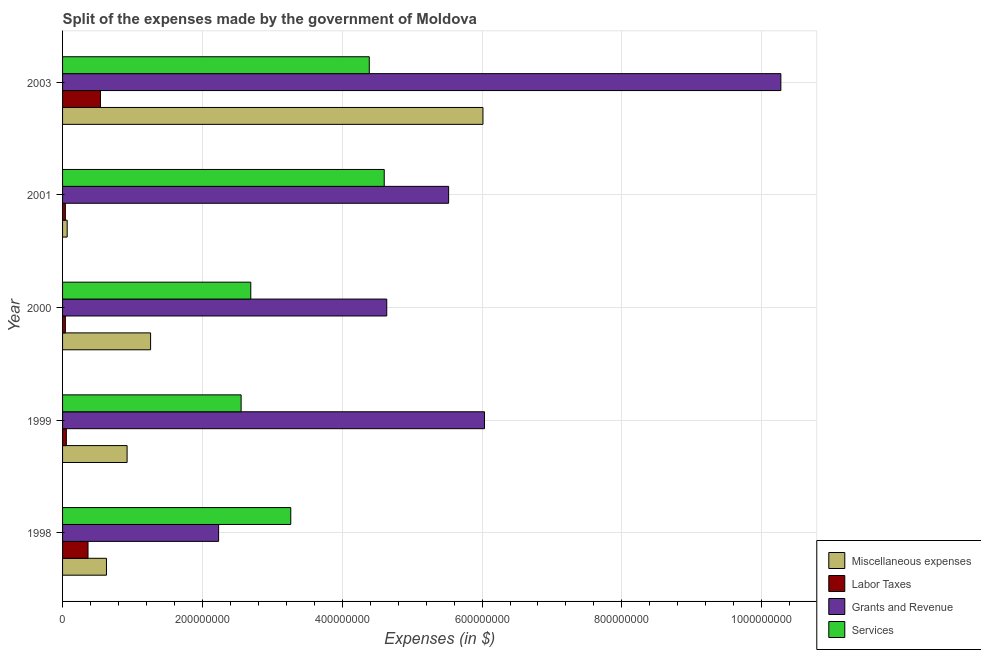How many different coloured bars are there?
Your answer should be compact. 4. What is the label of the 3rd group of bars from the top?
Provide a succinct answer. 2000. What is the amount spent on services in 2001?
Give a very brief answer. 4.60e+08. Across all years, what is the maximum amount spent on labor taxes?
Give a very brief answer. 5.42e+07. Across all years, what is the minimum amount spent on miscellaneous expenses?
Your answer should be compact. 6.60e+06. In which year was the amount spent on miscellaneous expenses maximum?
Provide a succinct answer. 2003. In which year was the amount spent on labor taxes minimum?
Provide a succinct answer. 2000. What is the total amount spent on grants and revenue in the graph?
Your response must be concise. 2.87e+09. What is the difference between the amount spent on miscellaneous expenses in 1998 and that in 1999?
Make the answer very short. -2.95e+07. What is the difference between the amount spent on grants and revenue in 2000 and the amount spent on miscellaneous expenses in 1998?
Keep it short and to the point. 4.01e+08. What is the average amount spent on grants and revenue per year?
Ensure brevity in your answer.  5.74e+08. In the year 1998, what is the difference between the amount spent on labor taxes and amount spent on miscellaneous expenses?
Your response must be concise. -2.64e+07. What is the ratio of the amount spent on grants and revenue in 2001 to that in 2003?
Your response must be concise. 0.54. Is the amount spent on labor taxes in 1998 less than that in 2001?
Offer a terse response. No. Is the difference between the amount spent on grants and revenue in 1999 and 2001 greater than the difference between the amount spent on services in 1999 and 2001?
Offer a terse response. Yes. What is the difference between the highest and the second highest amount spent on labor taxes?
Offer a terse response. 1.78e+07. What is the difference between the highest and the lowest amount spent on labor taxes?
Offer a terse response. 5.02e+07. In how many years, is the amount spent on miscellaneous expenses greater than the average amount spent on miscellaneous expenses taken over all years?
Offer a terse response. 1. What does the 4th bar from the top in 1998 represents?
Offer a terse response. Miscellaneous expenses. What does the 2nd bar from the bottom in 1998 represents?
Ensure brevity in your answer.  Labor Taxes. How many years are there in the graph?
Your response must be concise. 5. What is the difference between two consecutive major ticks on the X-axis?
Offer a very short reply. 2.00e+08. Are the values on the major ticks of X-axis written in scientific E-notation?
Your response must be concise. No. Does the graph contain any zero values?
Offer a very short reply. No. Does the graph contain grids?
Offer a terse response. Yes. Where does the legend appear in the graph?
Offer a terse response. Bottom right. How are the legend labels stacked?
Provide a succinct answer. Vertical. What is the title of the graph?
Keep it short and to the point. Split of the expenses made by the government of Moldova. Does "Bird species" appear as one of the legend labels in the graph?
Make the answer very short. No. What is the label or title of the X-axis?
Offer a very short reply. Expenses (in $). What is the Expenses (in $) in Miscellaneous expenses in 1998?
Offer a very short reply. 6.28e+07. What is the Expenses (in $) of Labor Taxes in 1998?
Make the answer very short. 3.64e+07. What is the Expenses (in $) of Grants and Revenue in 1998?
Provide a short and direct response. 2.23e+08. What is the Expenses (in $) of Services in 1998?
Ensure brevity in your answer.  3.26e+08. What is the Expenses (in $) in Miscellaneous expenses in 1999?
Give a very brief answer. 9.23e+07. What is the Expenses (in $) of Labor Taxes in 1999?
Ensure brevity in your answer.  5.40e+06. What is the Expenses (in $) in Grants and Revenue in 1999?
Offer a terse response. 6.04e+08. What is the Expenses (in $) of Services in 1999?
Your answer should be very brief. 2.55e+08. What is the Expenses (in $) in Miscellaneous expenses in 2000?
Your answer should be compact. 1.26e+08. What is the Expenses (in $) of Labor Taxes in 2000?
Your response must be concise. 4.00e+06. What is the Expenses (in $) in Grants and Revenue in 2000?
Give a very brief answer. 4.64e+08. What is the Expenses (in $) of Services in 2000?
Offer a very short reply. 2.69e+08. What is the Expenses (in $) of Miscellaneous expenses in 2001?
Offer a very short reply. 6.60e+06. What is the Expenses (in $) in Grants and Revenue in 2001?
Make the answer very short. 5.52e+08. What is the Expenses (in $) of Services in 2001?
Ensure brevity in your answer.  4.60e+08. What is the Expenses (in $) of Miscellaneous expenses in 2003?
Ensure brevity in your answer.  6.01e+08. What is the Expenses (in $) in Labor Taxes in 2003?
Provide a short and direct response. 5.42e+07. What is the Expenses (in $) of Grants and Revenue in 2003?
Offer a terse response. 1.03e+09. What is the Expenses (in $) of Services in 2003?
Offer a very short reply. 4.39e+08. Across all years, what is the maximum Expenses (in $) of Miscellaneous expenses?
Provide a succinct answer. 6.01e+08. Across all years, what is the maximum Expenses (in $) of Labor Taxes?
Offer a very short reply. 5.42e+07. Across all years, what is the maximum Expenses (in $) of Grants and Revenue?
Give a very brief answer. 1.03e+09. Across all years, what is the maximum Expenses (in $) in Services?
Offer a terse response. 4.60e+08. Across all years, what is the minimum Expenses (in $) of Miscellaneous expenses?
Provide a succinct answer. 6.60e+06. Across all years, what is the minimum Expenses (in $) of Labor Taxes?
Offer a very short reply. 4.00e+06. Across all years, what is the minimum Expenses (in $) of Grants and Revenue?
Give a very brief answer. 2.23e+08. Across all years, what is the minimum Expenses (in $) of Services?
Your answer should be very brief. 2.55e+08. What is the total Expenses (in $) in Miscellaneous expenses in the graph?
Give a very brief answer. 8.89e+08. What is the total Expenses (in $) in Labor Taxes in the graph?
Offer a terse response. 1.04e+08. What is the total Expenses (in $) of Grants and Revenue in the graph?
Your answer should be compact. 2.87e+09. What is the total Expenses (in $) in Services in the graph?
Your response must be concise. 1.75e+09. What is the difference between the Expenses (in $) of Miscellaneous expenses in 1998 and that in 1999?
Give a very brief answer. -2.95e+07. What is the difference between the Expenses (in $) of Labor Taxes in 1998 and that in 1999?
Give a very brief answer. 3.10e+07. What is the difference between the Expenses (in $) in Grants and Revenue in 1998 and that in 1999?
Your response must be concise. -3.80e+08. What is the difference between the Expenses (in $) in Services in 1998 and that in 1999?
Provide a succinct answer. 7.10e+07. What is the difference between the Expenses (in $) of Miscellaneous expenses in 1998 and that in 2000?
Give a very brief answer. -6.31e+07. What is the difference between the Expenses (in $) of Labor Taxes in 1998 and that in 2000?
Make the answer very short. 3.24e+07. What is the difference between the Expenses (in $) of Grants and Revenue in 1998 and that in 2000?
Your response must be concise. -2.40e+08. What is the difference between the Expenses (in $) in Services in 1998 and that in 2000?
Your answer should be very brief. 5.72e+07. What is the difference between the Expenses (in $) of Miscellaneous expenses in 1998 and that in 2001?
Keep it short and to the point. 5.62e+07. What is the difference between the Expenses (in $) of Labor Taxes in 1998 and that in 2001?
Your answer should be compact. 3.24e+07. What is the difference between the Expenses (in $) in Grants and Revenue in 1998 and that in 2001?
Ensure brevity in your answer.  -3.29e+08. What is the difference between the Expenses (in $) in Services in 1998 and that in 2001?
Provide a succinct answer. -1.34e+08. What is the difference between the Expenses (in $) of Miscellaneous expenses in 1998 and that in 2003?
Offer a very short reply. -5.38e+08. What is the difference between the Expenses (in $) of Labor Taxes in 1998 and that in 2003?
Your answer should be compact. -1.78e+07. What is the difference between the Expenses (in $) in Grants and Revenue in 1998 and that in 2003?
Your response must be concise. -8.04e+08. What is the difference between the Expenses (in $) of Services in 1998 and that in 2003?
Offer a very short reply. -1.12e+08. What is the difference between the Expenses (in $) of Miscellaneous expenses in 1999 and that in 2000?
Your answer should be very brief. -3.36e+07. What is the difference between the Expenses (in $) in Labor Taxes in 1999 and that in 2000?
Make the answer very short. 1.40e+06. What is the difference between the Expenses (in $) in Grants and Revenue in 1999 and that in 2000?
Your answer should be compact. 1.40e+08. What is the difference between the Expenses (in $) of Services in 1999 and that in 2000?
Make the answer very short. -1.38e+07. What is the difference between the Expenses (in $) of Miscellaneous expenses in 1999 and that in 2001?
Make the answer very short. 8.57e+07. What is the difference between the Expenses (in $) of Labor Taxes in 1999 and that in 2001?
Your answer should be very brief. 1.40e+06. What is the difference between the Expenses (in $) in Grants and Revenue in 1999 and that in 2001?
Keep it short and to the point. 5.13e+07. What is the difference between the Expenses (in $) of Services in 1999 and that in 2001?
Your answer should be very brief. -2.05e+08. What is the difference between the Expenses (in $) of Miscellaneous expenses in 1999 and that in 2003?
Provide a succinct answer. -5.09e+08. What is the difference between the Expenses (in $) in Labor Taxes in 1999 and that in 2003?
Provide a succinct answer. -4.88e+07. What is the difference between the Expenses (in $) in Grants and Revenue in 1999 and that in 2003?
Give a very brief answer. -4.24e+08. What is the difference between the Expenses (in $) in Services in 1999 and that in 2003?
Your response must be concise. -1.83e+08. What is the difference between the Expenses (in $) in Miscellaneous expenses in 2000 and that in 2001?
Your answer should be compact. 1.19e+08. What is the difference between the Expenses (in $) of Grants and Revenue in 2000 and that in 2001?
Make the answer very short. -8.85e+07. What is the difference between the Expenses (in $) in Services in 2000 and that in 2001?
Ensure brevity in your answer.  -1.91e+08. What is the difference between the Expenses (in $) in Miscellaneous expenses in 2000 and that in 2003?
Make the answer very short. -4.75e+08. What is the difference between the Expenses (in $) of Labor Taxes in 2000 and that in 2003?
Provide a short and direct response. -5.02e+07. What is the difference between the Expenses (in $) of Grants and Revenue in 2000 and that in 2003?
Ensure brevity in your answer.  -5.64e+08. What is the difference between the Expenses (in $) in Services in 2000 and that in 2003?
Make the answer very short. -1.70e+08. What is the difference between the Expenses (in $) of Miscellaneous expenses in 2001 and that in 2003?
Give a very brief answer. -5.95e+08. What is the difference between the Expenses (in $) in Labor Taxes in 2001 and that in 2003?
Offer a very short reply. -5.02e+07. What is the difference between the Expenses (in $) in Grants and Revenue in 2001 and that in 2003?
Give a very brief answer. -4.75e+08. What is the difference between the Expenses (in $) of Services in 2001 and that in 2003?
Your response must be concise. 2.14e+07. What is the difference between the Expenses (in $) of Miscellaneous expenses in 1998 and the Expenses (in $) of Labor Taxes in 1999?
Your response must be concise. 5.74e+07. What is the difference between the Expenses (in $) of Miscellaneous expenses in 1998 and the Expenses (in $) of Grants and Revenue in 1999?
Offer a terse response. -5.41e+08. What is the difference between the Expenses (in $) in Miscellaneous expenses in 1998 and the Expenses (in $) in Services in 1999?
Provide a succinct answer. -1.93e+08. What is the difference between the Expenses (in $) in Labor Taxes in 1998 and the Expenses (in $) in Grants and Revenue in 1999?
Offer a very short reply. -5.67e+08. What is the difference between the Expenses (in $) of Labor Taxes in 1998 and the Expenses (in $) of Services in 1999?
Provide a succinct answer. -2.19e+08. What is the difference between the Expenses (in $) of Grants and Revenue in 1998 and the Expenses (in $) of Services in 1999?
Your answer should be very brief. -3.22e+07. What is the difference between the Expenses (in $) in Miscellaneous expenses in 1998 and the Expenses (in $) in Labor Taxes in 2000?
Your answer should be very brief. 5.88e+07. What is the difference between the Expenses (in $) in Miscellaneous expenses in 1998 and the Expenses (in $) in Grants and Revenue in 2000?
Offer a terse response. -4.01e+08. What is the difference between the Expenses (in $) in Miscellaneous expenses in 1998 and the Expenses (in $) in Services in 2000?
Offer a very short reply. -2.06e+08. What is the difference between the Expenses (in $) in Labor Taxes in 1998 and the Expenses (in $) in Grants and Revenue in 2000?
Your answer should be compact. -4.27e+08. What is the difference between the Expenses (in $) of Labor Taxes in 1998 and the Expenses (in $) of Services in 2000?
Make the answer very short. -2.33e+08. What is the difference between the Expenses (in $) of Grants and Revenue in 1998 and the Expenses (in $) of Services in 2000?
Keep it short and to the point. -4.60e+07. What is the difference between the Expenses (in $) of Miscellaneous expenses in 1998 and the Expenses (in $) of Labor Taxes in 2001?
Give a very brief answer. 5.88e+07. What is the difference between the Expenses (in $) in Miscellaneous expenses in 1998 and the Expenses (in $) in Grants and Revenue in 2001?
Your answer should be very brief. -4.89e+08. What is the difference between the Expenses (in $) in Miscellaneous expenses in 1998 and the Expenses (in $) in Services in 2001?
Your answer should be compact. -3.97e+08. What is the difference between the Expenses (in $) of Labor Taxes in 1998 and the Expenses (in $) of Grants and Revenue in 2001?
Give a very brief answer. -5.16e+08. What is the difference between the Expenses (in $) in Labor Taxes in 1998 and the Expenses (in $) in Services in 2001?
Your answer should be compact. -4.24e+08. What is the difference between the Expenses (in $) in Grants and Revenue in 1998 and the Expenses (in $) in Services in 2001?
Your answer should be very brief. -2.37e+08. What is the difference between the Expenses (in $) in Miscellaneous expenses in 1998 and the Expenses (in $) in Labor Taxes in 2003?
Provide a short and direct response. 8.60e+06. What is the difference between the Expenses (in $) of Miscellaneous expenses in 1998 and the Expenses (in $) of Grants and Revenue in 2003?
Make the answer very short. -9.65e+08. What is the difference between the Expenses (in $) in Miscellaneous expenses in 1998 and the Expenses (in $) in Services in 2003?
Make the answer very short. -3.76e+08. What is the difference between the Expenses (in $) of Labor Taxes in 1998 and the Expenses (in $) of Grants and Revenue in 2003?
Your answer should be very brief. -9.91e+08. What is the difference between the Expenses (in $) of Labor Taxes in 1998 and the Expenses (in $) of Services in 2003?
Provide a succinct answer. -4.02e+08. What is the difference between the Expenses (in $) of Grants and Revenue in 1998 and the Expenses (in $) of Services in 2003?
Ensure brevity in your answer.  -2.16e+08. What is the difference between the Expenses (in $) in Miscellaneous expenses in 1999 and the Expenses (in $) in Labor Taxes in 2000?
Make the answer very short. 8.83e+07. What is the difference between the Expenses (in $) of Miscellaneous expenses in 1999 and the Expenses (in $) of Grants and Revenue in 2000?
Provide a short and direct response. -3.71e+08. What is the difference between the Expenses (in $) in Miscellaneous expenses in 1999 and the Expenses (in $) in Services in 2000?
Provide a succinct answer. -1.77e+08. What is the difference between the Expenses (in $) in Labor Taxes in 1999 and the Expenses (in $) in Grants and Revenue in 2000?
Give a very brief answer. -4.58e+08. What is the difference between the Expenses (in $) of Labor Taxes in 1999 and the Expenses (in $) of Services in 2000?
Give a very brief answer. -2.64e+08. What is the difference between the Expenses (in $) in Grants and Revenue in 1999 and the Expenses (in $) in Services in 2000?
Make the answer very short. 3.34e+08. What is the difference between the Expenses (in $) of Miscellaneous expenses in 1999 and the Expenses (in $) of Labor Taxes in 2001?
Your answer should be very brief. 8.83e+07. What is the difference between the Expenses (in $) of Miscellaneous expenses in 1999 and the Expenses (in $) of Grants and Revenue in 2001?
Your response must be concise. -4.60e+08. What is the difference between the Expenses (in $) of Miscellaneous expenses in 1999 and the Expenses (in $) of Services in 2001?
Offer a very short reply. -3.68e+08. What is the difference between the Expenses (in $) of Labor Taxes in 1999 and the Expenses (in $) of Grants and Revenue in 2001?
Make the answer very short. -5.47e+08. What is the difference between the Expenses (in $) in Labor Taxes in 1999 and the Expenses (in $) in Services in 2001?
Offer a terse response. -4.55e+08. What is the difference between the Expenses (in $) in Grants and Revenue in 1999 and the Expenses (in $) in Services in 2001?
Provide a short and direct response. 1.43e+08. What is the difference between the Expenses (in $) in Miscellaneous expenses in 1999 and the Expenses (in $) in Labor Taxes in 2003?
Your answer should be compact. 3.81e+07. What is the difference between the Expenses (in $) of Miscellaneous expenses in 1999 and the Expenses (in $) of Grants and Revenue in 2003?
Make the answer very short. -9.35e+08. What is the difference between the Expenses (in $) of Miscellaneous expenses in 1999 and the Expenses (in $) of Services in 2003?
Your response must be concise. -3.46e+08. What is the difference between the Expenses (in $) in Labor Taxes in 1999 and the Expenses (in $) in Grants and Revenue in 2003?
Ensure brevity in your answer.  -1.02e+09. What is the difference between the Expenses (in $) of Labor Taxes in 1999 and the Expenses (in $) of Services in 2003?
Provide a succinct answer. -4.33e+08. What is the difference between the Expenses (in $) in Grants and Revenue in 1999 and the Expenses (in $) in Services in 2003?
Make the answer very short. 1.65e+08. What is the difference between the Expenses (in $) of Miscellaneous expenses in 2000 and the Expenses (in $) of Labor Taxes in 2001?
Ensure brevity in your answer.  1.22e+08. What is the difference between the Expenses (in $) in Miscellaneous expenses in 2000 and the Expenses (in $) in Grants and Revenue in 2001?
Give a very brief answer. -4.26e+08. What is the difference between the Expenses (in $) of Miscellaneous expenses in 2000 and the Expenses (in $) of Services in 2001?
Your answer should be very brief. -3.34e+08. What is the difference between the Expenses (in $) of Labor Taxes in 2000 and the Expenses (in $) of Grants and Revenue in 2001?
Give a very brief answer. -5.48e+08. What is the difference between the Expenses (in $) of Labor Taxes in 2000 and the Expenses (in $) of Services in 2001?
Ensure brevity in your answer.  -4.56e+08. What is the difference between the Expenses (in $) in Grants and Revenue in 2000 and the Expenses (in $) in Services in 2001?
Provide a short and direct response. 3.60e+06. What is the difference between the Expenses (in $) of Miscellaneous expenses in 2000 and the Expenses (in $) of Labor Taxes in 2003?
Offer a terse response. 7.17e+07. What is the difference between the Expenses (in $) in Miscellaneous expenses in 2000 and the Expenses (in $) in Grants and Revenue in 2003?
Ensure brevity in your answer.  -9.02e+08. What is the difference between the Expenses (in $) of Miscellaneous expenses in 2000 and the Expenses (in $) of Services in 2003?
Offer a very short reply. -3.13e+08. What is the difference between the Expenses (in $) of Labor Taxes in 2000 and the Expenses (in $) of Grants and Revenue in 2003?
Give a very brief answer. -1.02e+09. What is the difference between the Expenses (in $) of Labor Taxes in 2000 and the Expenses (in $) of Services in 2003?
Give a very brief answer. -4.35e+08. What is the difference between the Expenses (in $) of Grants and Revenue in 2000 and the Expenses (in $) of Services in 2003?
Offer a very short reply. 2.50e+07. What is the difference between the Expenses (in $) of Miscellaneous expenses in 2001 and the Expenses (in $) of Labor Taxes in 2003?
Provide a succinct answer. -4.76e+07. What is the difference between the Expenses (in $) of Miscellaneous expenses in 2001 and the Expenses (in $) of Grants and Revenue in 2003?
Provide a succinct answer. -1.02e+09. What is the difference between the Expenses (in $) in Miscellaneous expenses in 2001 and the Expenses (in $) in Services in 2003?
Provide a succinct answer. -4.32e+08. What is the difference between the Expenses (in $) of Labor Taxes in 2001 and the Expenses (in $) of Grants and Revenue in 2003?
Your answer should be very brief. -1.02e+09. What is the difference between the Expenses (in $) of Labor Taxes in 2001 and the Expenses (in $) of Services in 2003?
Offer a very short reply. -4.35e+08. What is the difference between the Expenses (in $) of Grants and Revenue in 2001 and the Expenses (in $) of Services in 2003?
Make the answer very short. 1.14e+08. What is the average Expenses (in $) of Miscellaneous expenses per year?
Provide a short and direct response. 1.78e+08. What is the average Expenses (in $) of Labor Taxes per year?
Give a very brief answer. 2.08e+07. What is the average Expenses (in $) of Grants and Revenue per year?
Offer a very short reply. 5.74e+08. What is the average Expenses (in $) in Services per year?
Keep it short and to the point. 3.50e+08. In the year 1998, what is the difference between the Expenses (in $) of Miscellaneous expenses and Expenses (in $) of Labor Taxes?
Your answer should be very brief. 2.64e+07. In the year 1998, what is the difference between the Expenses (in $) of Miscellaneous expenses and Expenses (in $) of Grants and Revenue?
Your response must be concise. -1.60e+08. In the year 1998, what is the difference between the Expenses (in $) in Miscellaneous expenses and Expenses (in $) in Services?
Ensure brevity in your answer.  -2.64e+08. In the year 1998, what is the difference between the Expenses (in $) of Labor Taxes and Expenses (in $) of Grants and Revenue?
Your answer should be very brief. -1.87e+08. In the year 1998, what is the difference between the Expenses (in $) in Labor Taxes and Expenses (in $) in Services?
Keep it short and to the point. -2.90e+08. In the year 1998, what is the difference between the Expenses (in $) in Grants and Revenue and Expenses (in $) in Services?
Offer a very short reply. -1.03e+08. In the year 1999, what is the difference between the Expenses (in $) of Miscellaneous expenses and Expenses (in $) of Labor Taxes?
Provide a short and direct response. 8.69e+07. In the year 1999, what is the difference between the Expenses (in $) of Miscellaneous expenses and Expenses (in $) of Grants and Revenue?
Ensure brevity in your answer.  -5.11e+08. In the year 1999, what is the difference between the Expenses (in $) of Miscellaneous expenses and Expenses (in $) of Services?
Your answer should be very brief. -1.63e+08. In the year 1999, what is the difference between the Expenses (in $) of Labor Taxes and Expenses (in $) of Grants and Revenue?
Your answer should be very brief. -5.98e+08. In the year 1999, what is the difference between the Expenses (in $) of Labor Taxes and Expenses (in $) of Services?
Give a very brief answer. -2.50e+08. In the year 1999, what is the difference between the Expenses (in $) in Grants and Revenue and Expenses (in $) in Services?
Provide a succinct answer. 3.48e+08. In the year 2000, what is the difference between the Expenses (in $) of Miscellaneous expenses and Expenses (in $) of Labor Taxes?
Your answer should be very brief. 1.22e+08. In the year 2000, what is the difference between the Expenses (in $) of Miscellaneous expenses and Expenses (in $) of Grants and Revenue?
Offer a terse response. -3.38e+08. In the year 2000, what is the difference between the Expenses (in $) in Miscellaneous expenses and Expenses (in $) in Services?
Keep it short and to the point. -1.43e+08. In the year 2000, what is the difference between the Expenses (in $) in Labor Taxes and Expenses (in $) in Grants and Revenue?
Ensure brevity in your answer.  -4.60e+08. In the year 2000, what is the difference between the Expenses (in $) of Labor Taxes and Expenses (in $) of Services?
Make the answer very short. -2.65e+08. In the year 2000, what is the difference between the Expenses (in $) of Grants and Revenue and Expenses (in $) of Services?
Keep it short and to the point. 1.94e+08. In the year 2001, what is the difference between the Expenses (in $) of Miscellaneous expenses and Expenses (in $) of Labor Taxes?
Keep it short and to the point. 2.60e+06. In the year 2001, what is the difference between the Expenses (in $) in Miscellaneous expenses and Expenses (in $) in Grants and Revenue?
Your response must be concise. -5.46e+08. In the year 2001, what is the difference between the Expenses (in $) in Miscellaneous expenses and Expenses (in $) in Services?
Your response must be concise. -4.54e+08. In the year 2001, what is the difference between the Expenses (in $) in Labor Taxes and Expenses (in $) in Grants and Revenue?
Provide a short and direct response. -5.48e+08. In the year 2001, what is the difference between the Expenses (in $) in Labor Taxes and Expenses (in $) in Services?
Give a very brief answer. -4.56e+08. In the year 2001, what is the difference between the Expenses (in $) in Grants and Revenue and Expenses (in $) in Services?
Provide a short and direct response. 9.21e+07. In the year 2003, what is the difference between the Expenses (in $) of Miscellaneous expenses and Expenses (in $) of Labor Taxes?
Give a very brief answer. 5.47e+08. In the year 2003, what is the difference between the Expenses (in $) in Miscellaneous expenses and Expenses (in $) in Grants and Revenue?
Offer a terse response. -4.26e+08. In the year 2003, what is the difference between the Expenses (in $) of Miscellaneous expenses and Expenses (in $) of Services?
Provide a succinct answer. 1.63e+08. In the year 2003, what is the difference between the Expenses (in $) in Labor Taxes and Expenses (in $) in Grants and Revenue?
Your response must be concise. -9.73e+08. In the year 2003, what is the difference between the Expenses (in $) of Labor Taxes and Expenses (in $) of Services?
Offer a terse response. -3.84e+08. In the year 2003, what is the difference between the Expenses (in $) in Grants and Revenue and Expenses (in $) in Services?
Give a very brief answer. 5.89e+08. What is the ratio of the Expenses (in $) in Miscellaneous expenses in 1998 to that in 1999?
Offer a terse response. 0.68. What is the ratio of the Expenses (in $) in Labor Taxes in 1998 to that in 1999?
Make the answer very short. 6.74. What is the ratio of the Expenses (in $) of Grants and Revenue in 1998 to that in 1999?
Your answer should be compact. 0.37. What is the ratio of the Expenses (in $) of Services in 1998 to that in 1999?
Your answer should be very brief. 1.28. What is the ratio of the Expenses (in $) of Miscellaneous expenses in 1998 to that in 2000?
Ensure brevity in your answer.  0.5. What is the ratio of the Expenses (in $) in Grants and Revenue in 1998 to that in 2000?
Make the answer very short. 0.48. What is the ratio of the Expenses (in $) of Services in 1998 to that in 2000?
Provide a succinct answer. 1.21. What is the ratio of the Expenses (in $) in Miscellaneous expenses in 1998 to that in 2001?
Offer a very short reply. 9.52. What is the ratio of the Expenses (in $) of Labor Taxes in 1998 to that in 2001?
Provide a short and direct response. 9.1. What is the ratio of the Expenses (in $) of Grants and Revenue in 1998 to that in 2001?
Make the answer very short. 0.4. What is the ratio of the Expenses (in $) of Services in 1998 to that in 2001?
Your answer should be very brief. 0.71. What is the ratio of the Expenses (in $) of Miscellaneous expenses in 1998 to that in 2003?
Your answer should be very brief. 0.1. What is the ratio of the Expenses (in $) in Labor Taxes in 1998 to that in 2003?
Provide a short and direct response. 0.67. What is the ratio of the Expenses (in $) in Grants and Revenue in 1998 to that in 2003?
Make the answer very short. 0.22. What is the ratio of the Expenses (in $) of Services in 1998 to that in 2003?
Offer a terse response. 0.74. What is the ratio of the Expenses (in $) of Miscellaneous expenses in 1999 to that in 2000?
Offer a very short reply. 0.73. What is the ratio of the Expenses (in $) in Labor Taxes in 1999 to that in 2000?
Offer a very short reply. 1.35. What is the ratio of the Expenses (in $) of Grants and Revenue in 1999 to that in 2000?
Keep it short and to the point. 1.3. What is the ratio of the Expenses (in $) of Services in 1999 to that in 2000?
Give a very brief answer. 0.95. What is the ratio of the Expenses (in $) in Miscellaneous expenses in 1999 to that in 2001?
Ensure brevity in your answer.  13.98. What is the ratio of the Expenses (in $) in Labor Taxes in 1999 to that in 2001?
Provide a succinct answer. 1.35. What is the ratio of the Expenses (in $) of Grants and Revenue in 1999 to that in 2001?
Provide a short and direct response. 1.09. What is the ratio of the Expenses (in $) of Services in 1999 to that in 2001?
Provide a succinct answer. 0.56. What is the ratio of the Expenses (in $) in Miscellaneous expenses in 1999 to that in 2003?
Ensure brevity in your answer.  0.15. What is the ratio of the Expenses (in $) of Labor Taxes in 1999 to that in 2003?
Make the answer very short. 0.1. What is the ratio of the Expenses (in $) of Grants and Revenue in 1999 to that in 2003?
Provide a short and direct response. 0.59. What is the ratio of the Expenses (in $) in Services in 1999 to that in 2003?
Make the answer very short. 0.58. What is the ratio of the Expenses (in $) of Miscellaneous expenses in 2000 to that in 2001?
Offer a very short reply. 19.08. What is the ratio of the Expenses (in $) of Grants and Revenue in 2000 to that in 2001?
Your response must be concise. 0.84. What is the ratio of the Expenses (in $) of Services in 2000 to that in 2001?
Make the answer very short. 0.59. What is the ratio of the Expenses (in $) in Miscellaneous expenses in 2000 to that in 2003?
Give a very brief answer. 0.21. What is the ratio of the Expenses (in $) in Labor Taxes in 2000 to that in 2003?
Your answer should be very brief. 0.07. What is the ratio of the Expenses (in $) in Grants and Revenue in 2000 to that in 2003?
Your answer should be compact. 0.45. What is the ratio of the Expenses (in $) of Services in 2000 to that in 2003?
Make the answer very short. 0.61. What is the ratio of the Expenses (in $) in Miscellaneous expenses in 2001 to that in 2003?
Offer a terse response. 0.01. What is the ratio of the Expenses (in $) in Labor Taxes in 2001 to that in 2003?
Give a very brief answer. 0.07. What is the ratio of the Expenses (in $) of Grants and Revenue in 2001 to that in 2003?
Keep it short and to the point. 0.54. What is the ratio of the Expenses (in $) in Services in 2001 to that in 2003?
Your answer should be very brief. 1.05. What is the difference between the highest and the second highest Expenses (in $) of Miscellaneous expenses?
Make the answer very short. 4.75e+08. What is the difference between the highest and the second highest Expenses (in $) in Labor Taxes?
Ensure brevity in your answer.  1.78e+07. What is the difference between the highest and the second highest Expenses (in $) of Grants and Revenue?
Keep it short and to the point. 4.24e+08. What is the difference between the highest and the second highest Expenses (in $) of Services?
Your answer should be very brief. 2.14e+07. What is the difference between the highest and the lowest Expenses (in $) in Miscellaneous expenses?
Make the answer very short. 5.95e+08. What is the difference between the highest and the lowest Expenses (in $) in Labor Taxes?
Your answer should be compact. 5.02e+07. What is the difference between the highest and the lowest Expenses (in $) in Grants and Revenue?
Offer a very short reply. 8.04e+08. What is the difference between the highest and the lowest Expenses (in $) in Services?
Your answer should be very brief. 2.05e+08. 